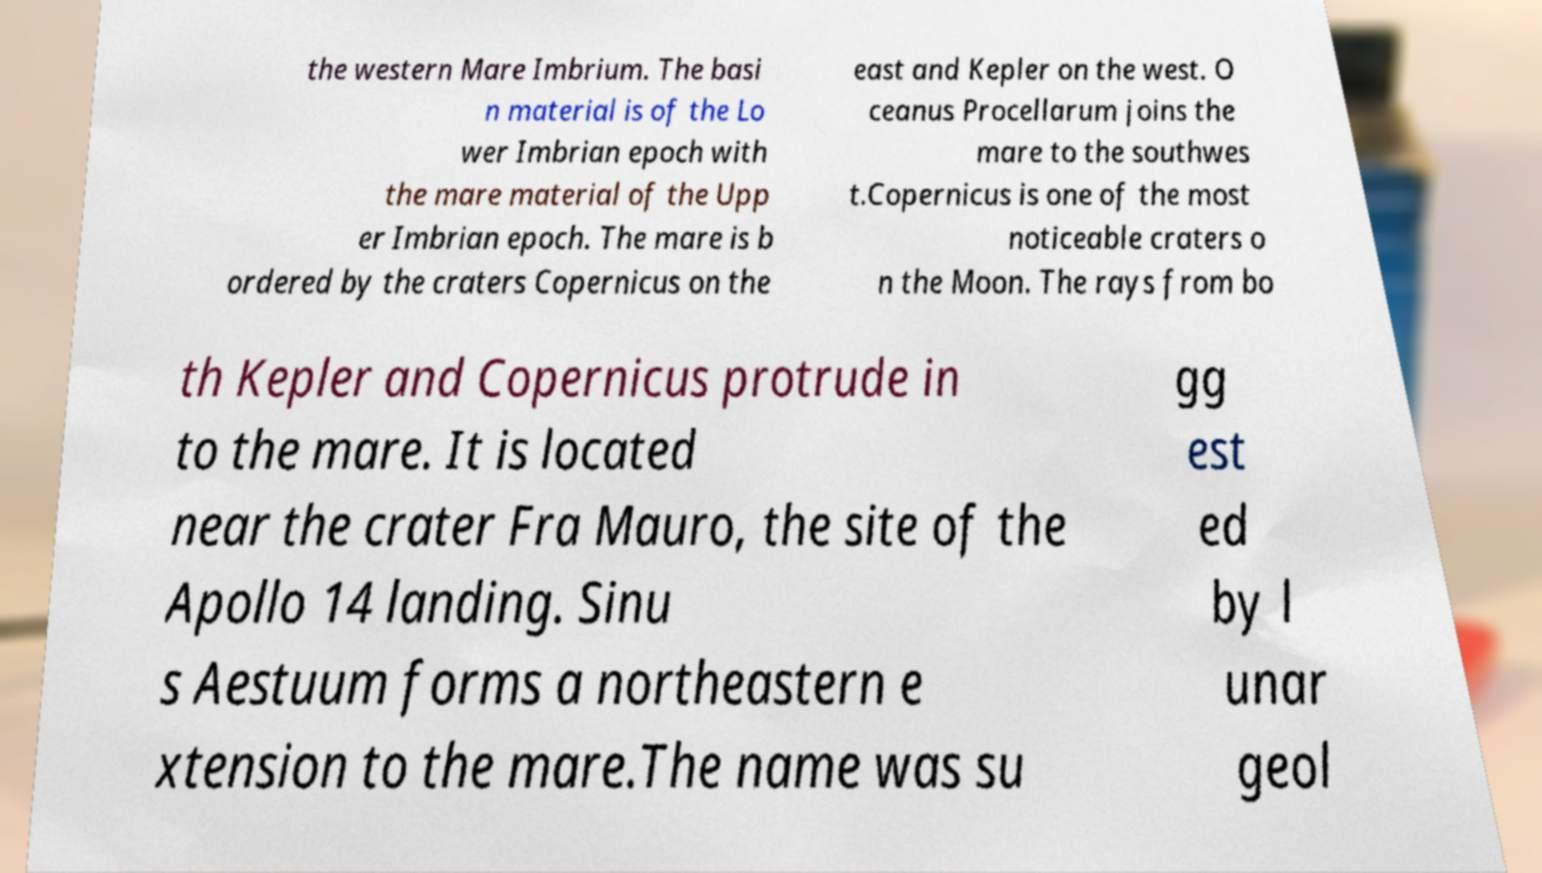Could you extract and type out the text from this image? the western Mare Imbrium. The basi n material is of the Lo wer Imbrian epoch with the mare material of the Upp er Imbrian epoch. The mare is b ordered by the craters Copernicus on the east and Kepler on the west. O ceanus Procellarum joins the mare to the southwes t.Copernicus is one of the most noticeable craters o n the Moon. The rays from bo th Kepler and Copernicus protrude in to the mare. It is located near the crater Fra Mauro, the site of the Apollo 14 landing. Sinu s Aestuum forms a northeastern e xtension to the mare.The name was su gg est ed by l unar geol 